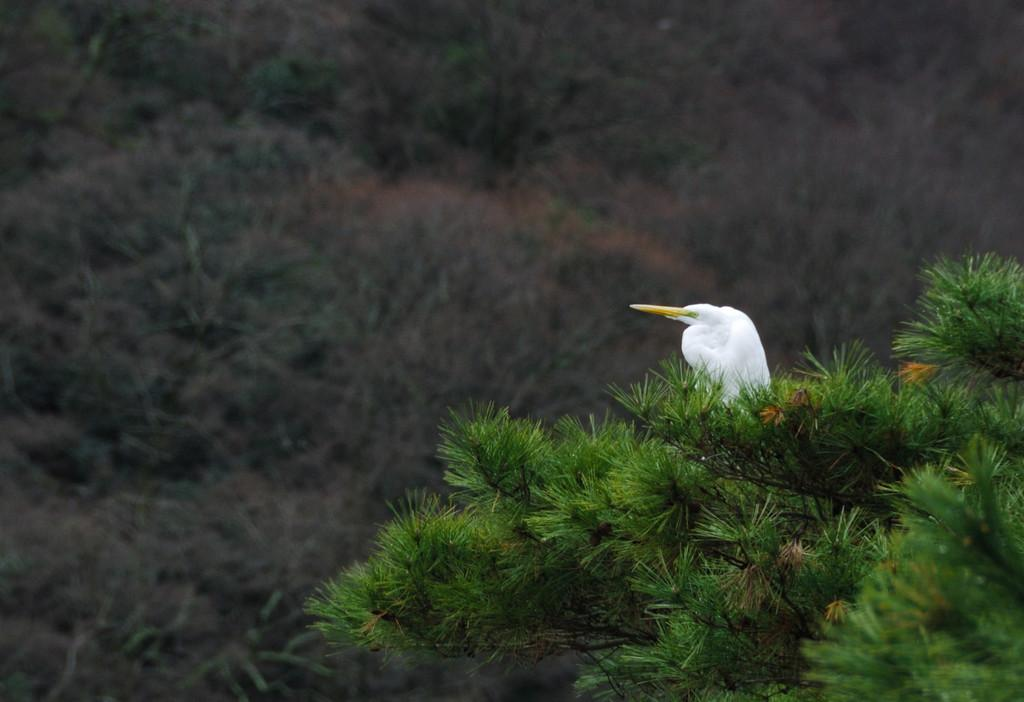What animal can be seen in the image? There is a bird on a tree in the image. What is the bird perched on? The bird is perched on a tree. What can be seen in the background of the image? There are trees visible in the background of the image. What substance is the bird using to communicate with the coach in the image? There is no coach or communication with a coach present in the image. The bird is simply perched on a tree. 